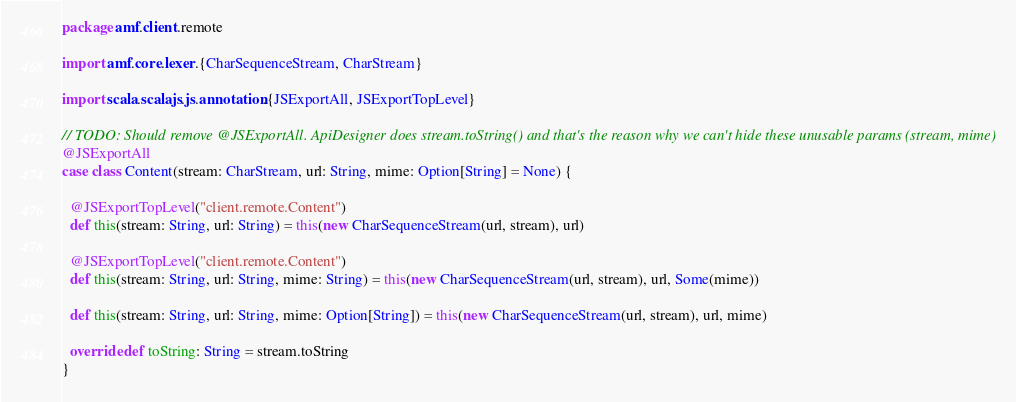<code> <loc_0><loc_0><loc_500><loc_500><_Scala_>package amf.client.remote

import amf.core.lexer.{CharSequenceStream, CharStream}

import scala.scalajs.js.annotation.{JSExportAll, JSExportTopLevel}

// TODO: Should remove @JSExportAll. ApiDesigner does stream.toString() and that's the reason why we can't hide these unusable params (stream, mime)
@JSExportAll
case class Content(stream: CharStream, url: String, mime: Option[String] = None) {

  @JSExportTopLevel("client.remote.Content")
  def this(stream: String, url: String) = this(new CharSequenceStream(url, stream), url)

  @JSExportTopLevel("client.remote.Content")
  def this(stream: String, url: String, mime: String) = this(new CharSequenceStream(url, stream), url, Some(mime))

  def this(stream: String, url: String, mime: Option[String]) = this(new CharSequenceStream(url, stream), url, mime)

  override def toString: String = stream.toString
}
</code> 